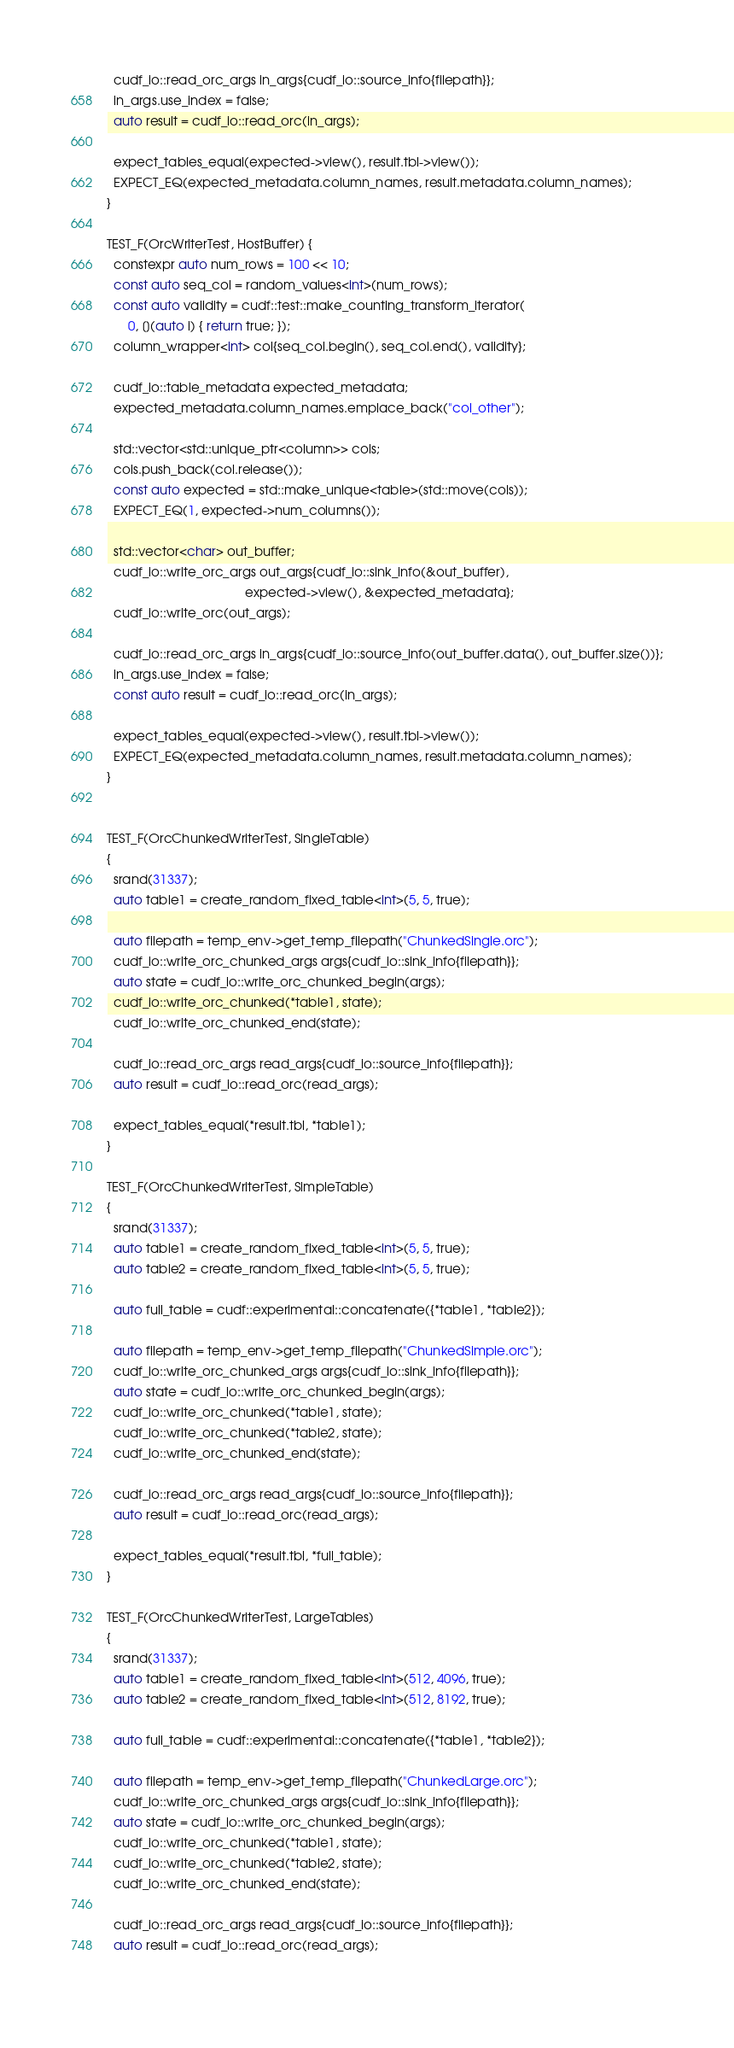<code> <loc_0><loc_0><loc_500><loc_500><_Cuda_>
  cudf_io::read_orc_args in_args{cudf_io::source_info{filepath}};
  in_args.use_index = false;
  auto result = cudf_io::read_orc(in_args);

  expect_tables_equal(expected->view(), result.tbl->view());
  EXPECT_EQ(expected_metadata.column_names, result.metadata.column_names);
}

TEST_F(OrcWriterTest, HostBuffer) {
  constexpr auto num_rows = 100 << 10;
  const auto seq_col = random_values<int>(num_rows);
  const auto validity = cudf::test::make_counting_transform_iterator(
      0, [](auto i) { return true; });
  column_wrapper<int> col{seq_col.begin(), seq_col.end(), validity};

  cudf_io::table_metadata expected_metadata;
  expected_metadata.column_names.emplace_back("col_other");

  std::vector<std::unique_ptr<column>> cols;
  cols.push_back(col.release());
  const auto expected = std::make_unique<table>(std::move(cols));
  EXPECT_EQ(1, expected->num_columns());

  std::vector<char> out_buffer;
  cudf_io::write_orc_args out_args{cudf_io::sink_info(&out_buffer),
                                       expected->view(), &expected_metadata};
  cudf_io::write_orc(out_args);

  cudf_io::read_orc_args in_args{cudf_io::source_info(out_buffer.data(), out_buffer.size())};
  in_args.use_index = false;
  const auto result = cudf_io::read_orc(in_args);

  expect_tables_equal(expected->view(), result.tbl->view());
  EXPECT_EQ(expected_metadata.column_names, result.metadata.column_names);
}


TEST_F(OrcChunkedWriterTest, SingleTable)
{
  srand(31337);
  auto table1 = create_random_fixed_table<int>(5, 5, true);      

  auto filepath = temp_env->get_temp_filepath("ChunkedSingle.orc");
  cudf_io::write_orc_chunked_args args{cudf_io::sink_info{filepath}};
  auto state = cudf_io::write_orc_chunked_begin(args);  
  cudf_io::write_orc_chunked(*table1, state);  
  cudf_io::write_orc_chunked_end(state);    

  cudf_io::read_orc_args read_args{cudf_io::source_info{filepath}};
  auto result = cudf_io::read_orc(read_args);
  
  expect_tables_equal(*result.tbl, *table1);    
}

TEST_F(OrcChunkedWriterTest, SimpleTable)
{
  srand(31337);
  auto table1 = create_random_fixed_table<int>(5, 5, true);
  auto table2 = create_random_fixed_table<int>(5, 5, true);
  
  auto full_table = cudf::experimental::concatenate({*table1, *table2});          

  auto filepath = temp_env->get_temp_filepath("ChunkedSimple.orc");
  cudf_io::write_orc_chunked_args args{cudf_io::sink_info{filepath}};
  auto state = cudf_io::write_orc_chunked_begin(args);  
  cudf_io::write_orc_chunked(*table1, state);
  cudf_io::write_orc_chunked(*table2, state);  
  cudf_io::write_orc_chunked_end(state);    

  cudf_io::read_orc_args read_args{cudf_io::source_info{filepath}};
  auto result = cudf_io::read_orc(read_args);
  
  expect_tables_equal(*result.tbl, *full_table);    
}

TEST_F(OrcChunkedWriterTest, LargeTables)
{
  srand(31337);
  auto table1 = create_random_fixed_table<int>(512, 4096, true);
  auto table2 = create_random_fixed_table<int>(512, 8192, true);
  
  auto full_table = cudf::experimental::concatenate({*table1, *table2});          

  auto filepath = temp_env->get_temp_filepath("ChunkedLarge.orc");
  cudf_io::write_orc_chunked_args args{cudf_io::sink_info{filepath}};
  auto state = cudf_io::write_orc_chunked_begin(args);  
  cudf_io::write_orc_chunked(*table1, state);
  cudf_io::write_orc_chunked(*table2, state);  
  cudf_io::write_orc_chunked_end(state);    

  cudf_io::read_orc_args read_args{cudf_io::source_info{filepath}};
  auto result = cudf_io::read_orc(read_args);
  </code> 